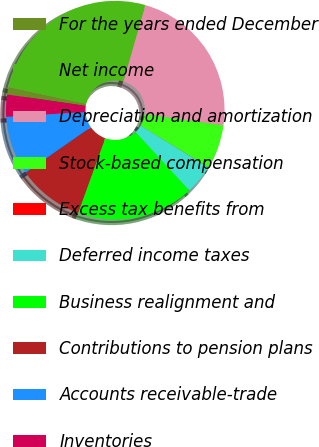Convert chart to OTSL. <chart><loc_0><loc_0><loc_500><loc_500><pie_chart><fcel>For the years ended December<fcel>Net income<fcel>Depreciation and amortization<fcel>Stock-based compensation<fcel>Excess tax benefits from<fcel>Deferred income taxes<fcel>Business realignment and<fcel>Contributions to pension plans<fcel>Accounts receivable-trade<fcel>Inventories<nl><fcel>1.11%<fcel>26.04%<fcel>22.79%<fcel>6.53%<fcel>0.03%<fcel>4.36%<fcel>17.37%<fcel>9.78%<fcel>8.7%<fcel>3.28%<nl></chart> 